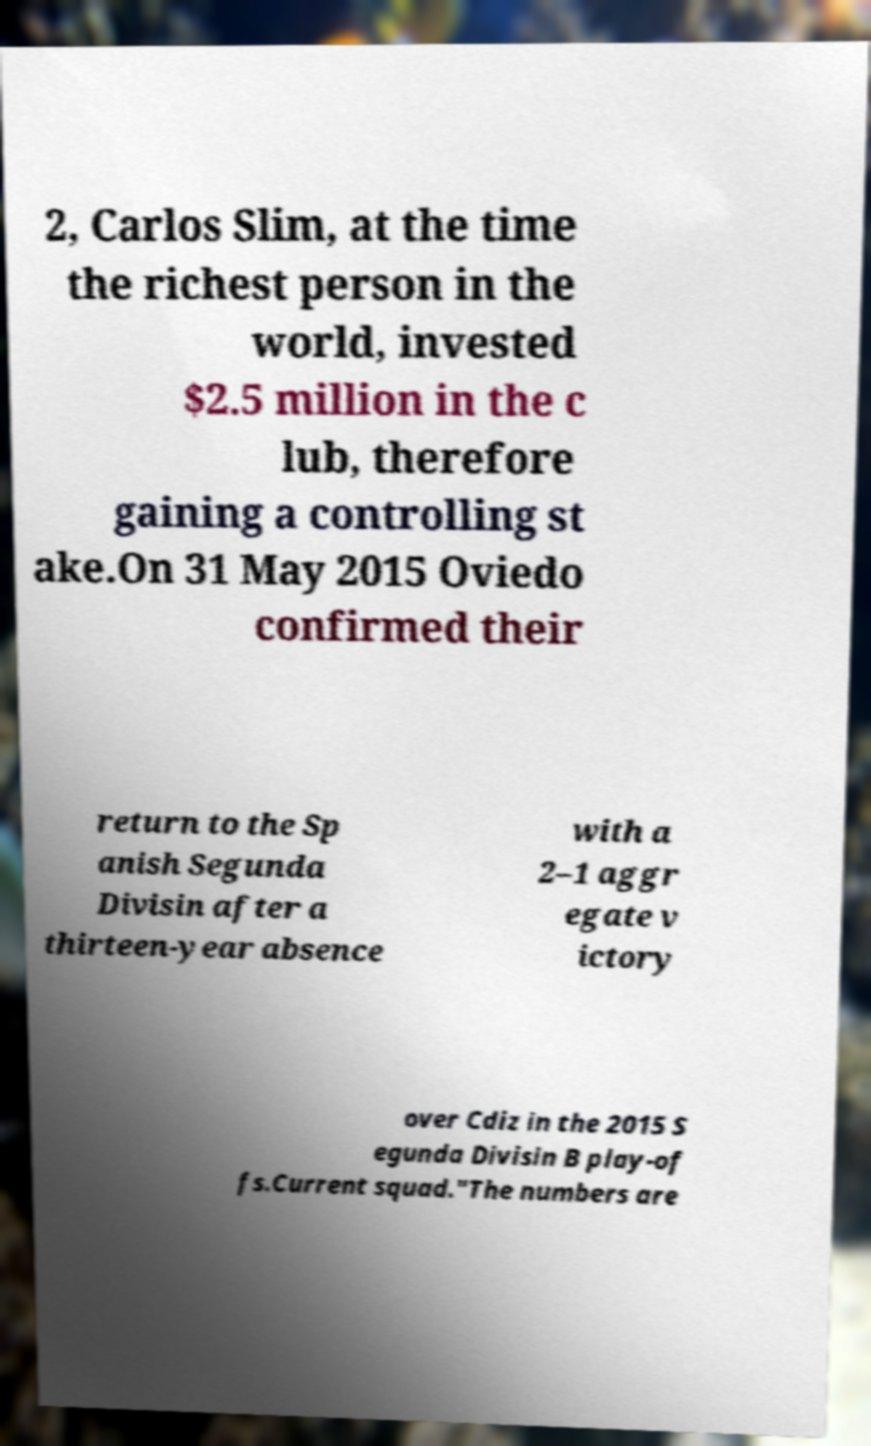Could you extract and type out the text from this image? 2, Carlos Slim, at the time the richest person in the world, invested $2.5 million in the c lub, therefore gaining a controlling st ake.On 31 May 2015 Oviedo confirmed their return to the Sp anish Segunda Divisin after a thirteen-year absence with a 2–1 aggr egate v ictory over Cdiz in the 2015 S egunda Divisin B play-of fs.Current squad."The numbers are 